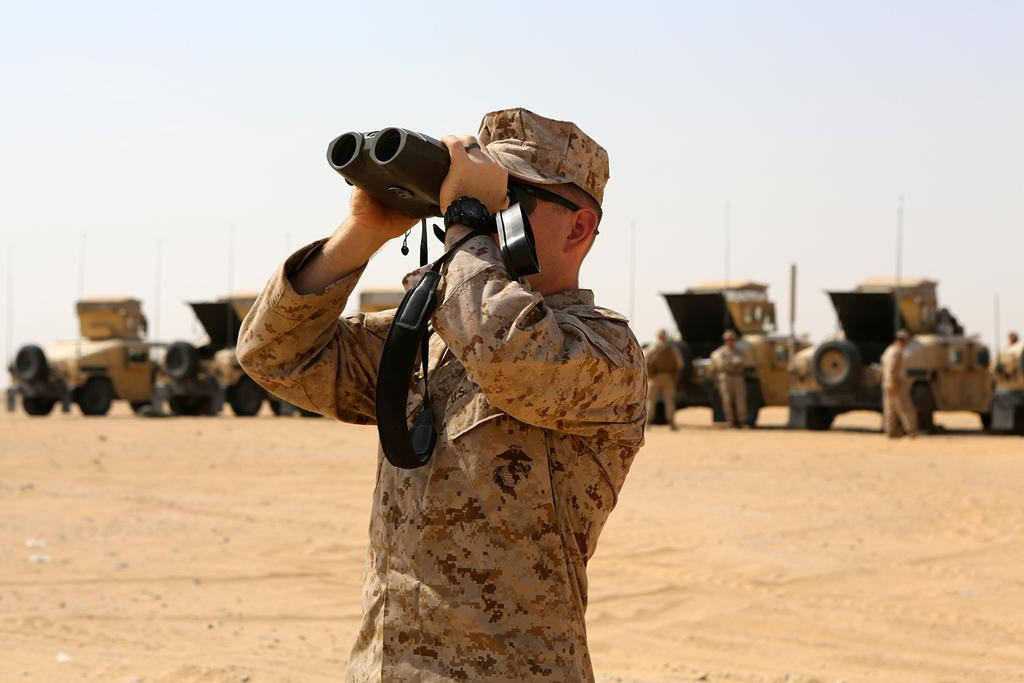What is the main subject of the image? There is a man standing in the center of the image. What is the man holding in the image? The man is holding binoculars. What can be seen in the background of the image? There are vehicles and people visible in the background of the image. What is visible at the top of the image? The sky is visible at the top of the image. What type of spark can be seen coming from the man's shoes in the image? There is no spark visible coming from the man's shoes in the image. What event is the man attending in the image? The image does not provide any information about an event the man might be attending. 